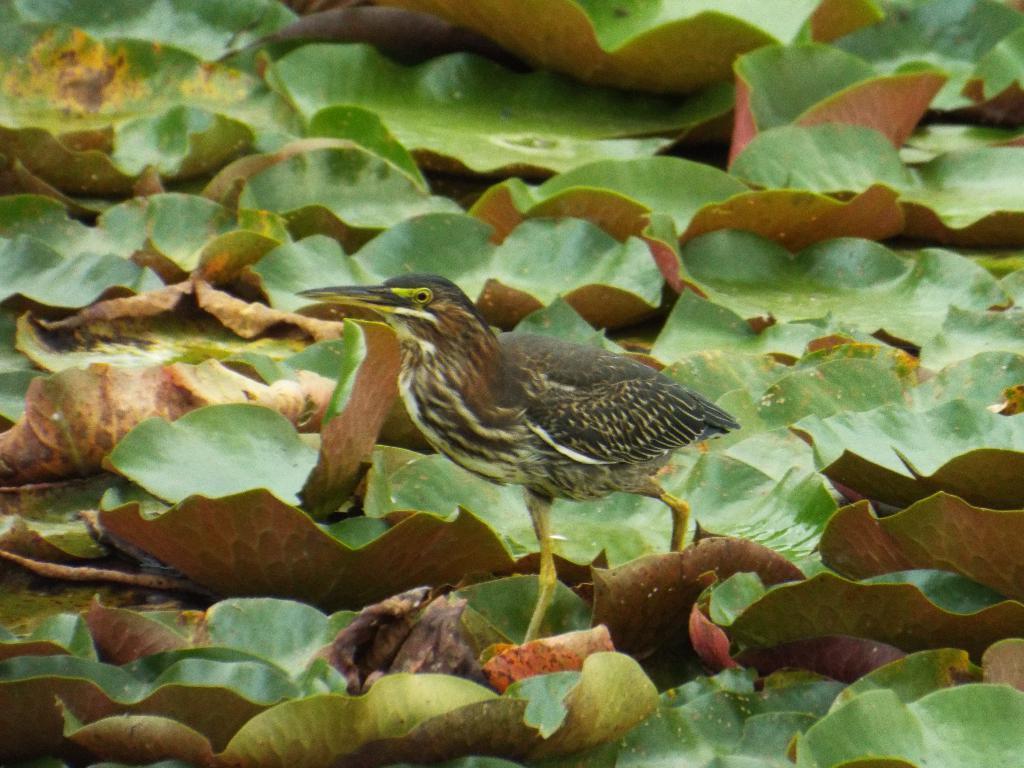How would you summarize this image in a sentence or two? In this image I can see the bird which is in black, white and brown color. The bird is on the leaves. These leaves are in green and brown color. 